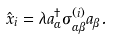<formula> <loc_0><loc_0><loc_500><loc_500>\hat { x } _ { i } = \lambda a ^ { \dagger } _ { \alpha } \sigma ^ { ( i ) } _ { \alpha \beta } a _ { \beta } .</formula> 